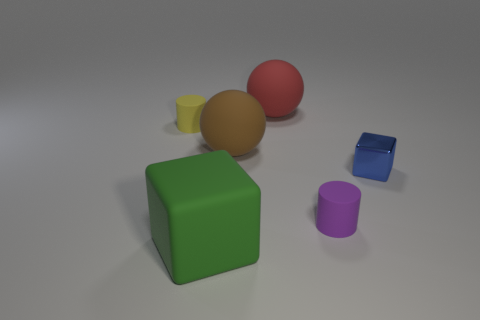Is there a matte cylinder of the same size as the brown rubber object?
Provide a succinct answer. No. What number of objects are either large matte objects in front of the yellow matte object or matte things in front of the red thing?
Provide a succinct answer. 4. There is a blue thing that is the same size as the yellow cylinder; what is its shape?
Your answer should be very brief. Cube. Are there any other matte objects of the same shape as the purple thing?
Offer a very short reply. Yes. Are there fewer large purple objects than big brown matte balls?
Keep it short and to the point. Yes. Is the size of the cube behind the large green matte thing the same as the cylinder right of the tiny yellow object?
Provide a short and direct response. Yes. What number of objects are either small yellow rubber cylinders or small shiny blocks?
Your answer should be very brief. 2. How big is the cube that is to the left of the red object?
Your answer should be very brief. Large. There is a tiny rubber object to the left of the big thing that is in front of the purple matte cylinder; how many tiny cylinders are in front of it?
Your response must be concise. 1. Does the small shiny object have the same color as the rubber cube?
Provide a short and direct response. No. 